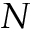Convert formula to latex. <formula><loc_0><loc_0><loc_500><loc_500>N</formula> 